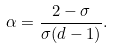Convert formula to latex. <formula><loc_0><loc_0><loc_500><loc_500>\alpha = \frac { 2 - \sigma } { \sigma ( d - 1 ) } .</formula> 